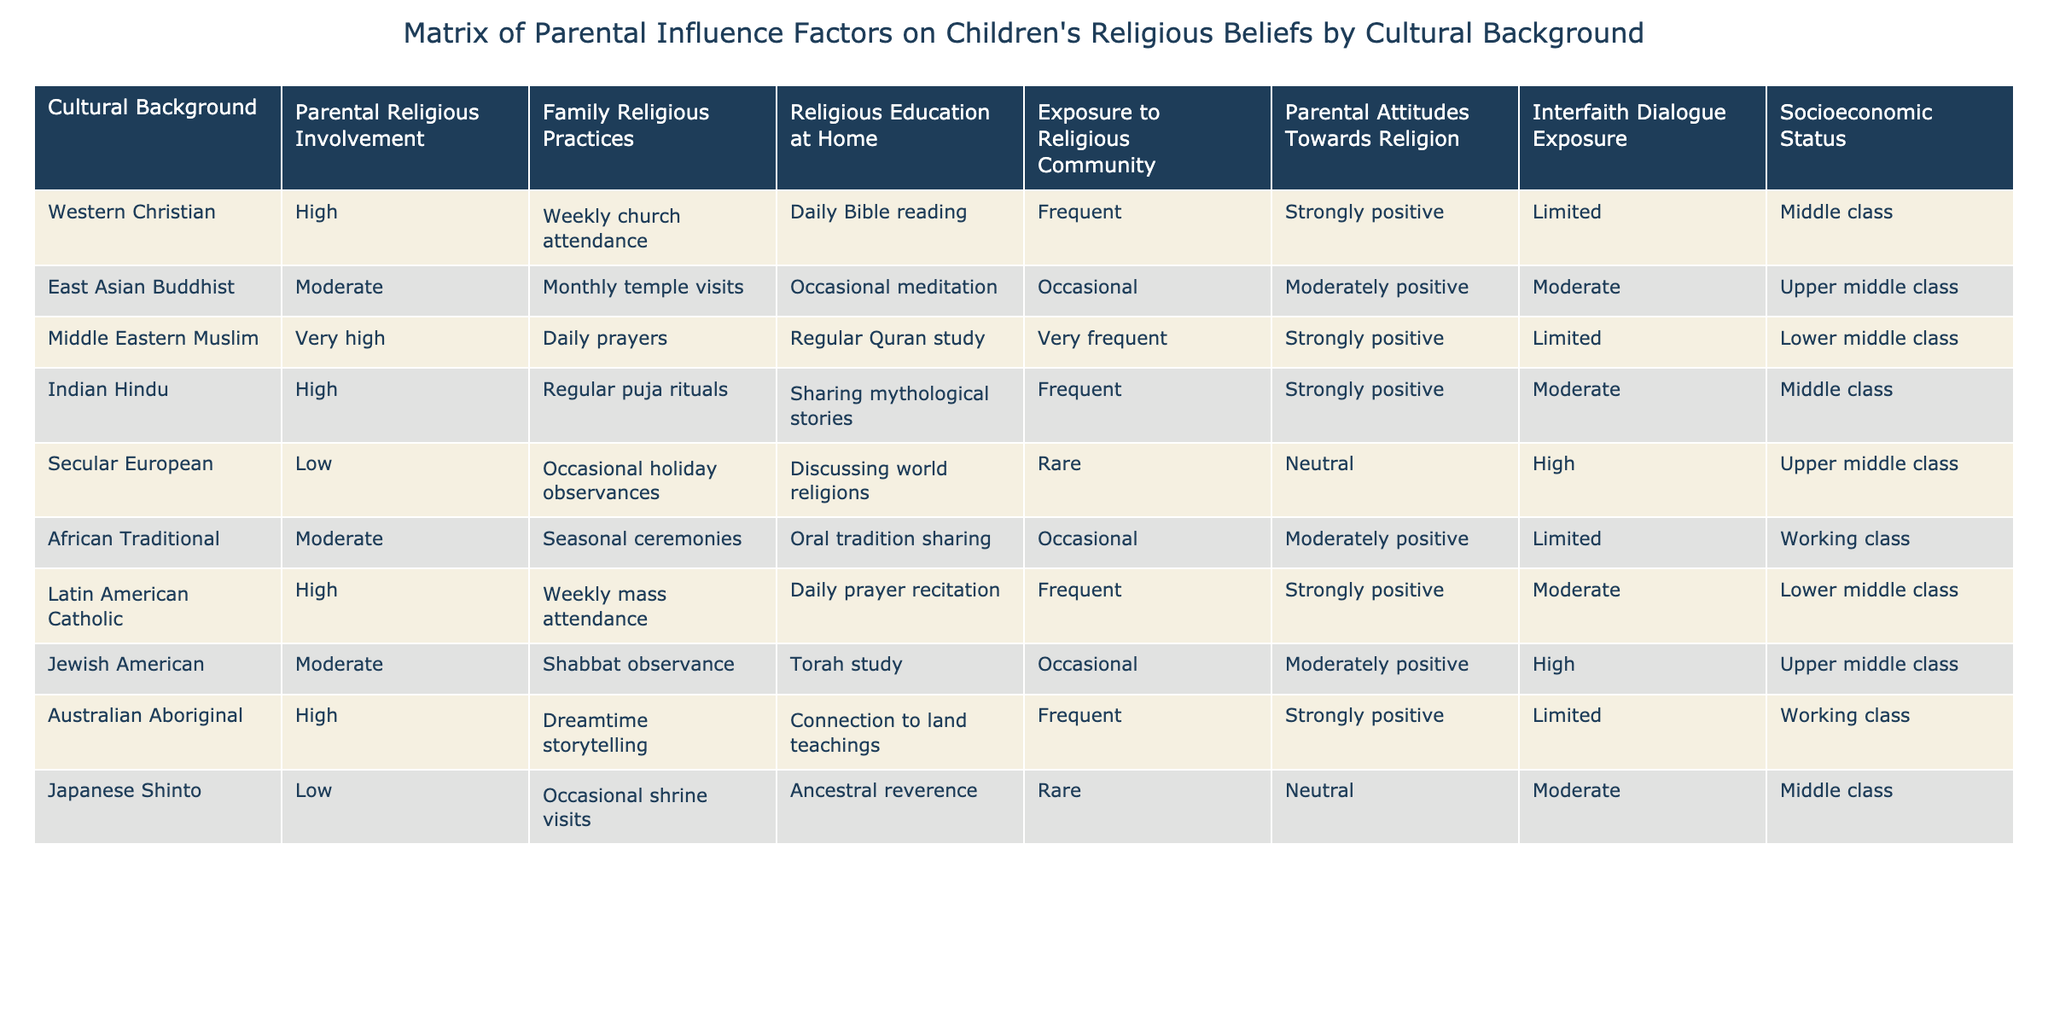What is the parental religious involvement level for the Middle Eastern Muslim background? The table indicates that the parental religious involvement level for the Middle Eastern Muslim background is "Very high."
Answer: Very high Which cultural background has the highest frequency of family religious practices? The Middle Eastern Muslim background shows "Daily prayers," indicating the highest frequency among the listed backgrounds.
Answer: Daily prayers Are exposure to religious communities and parental attitudes towards religion positively correlated in the Latin American Catholic background? The Latin American Catholic background has "Frequent" exposure to religious communities and "Strongly positive" parental attitudes, indicating a positive correlation.
Answer: Yes What is the socioeconomic status of the Secular European cultural background? The table shows that the socioeconomic status for the Secular European cultural background is "Upper middle class."
Answer: Upper middle class Which cultural background exhibits the least parental religious involvement? The Secular European background exhibits the least parental religious involvement with a level of "Low."
Answer: Low How many cultural backgrounds have moderate parental attitudes towards religion? The East Asian Buddhist and Jewish American cultural backgrounds both have "Moderately positive" parental attitudes, making a total of two.
Answer: 2 What is the difference in religious education at home between Australian Aboriginal and Japanese Shinto backgrounds? The Australian Aboriginal background has "Frequent" religious education while the Japanese Shinto has "Rare," making the difference - from frequent to rare.
Answer: Frequent - Rare Is there any background that has high parental involvement but low exposure to religious communities? The Australian Aboriginal background has "High" parental involvement but "Limited" exposure to religious communities.
Answer: Yes What can be said about the relationship between socioeconomic status and family religious practices in the East Asian Buddhist background? The East Asian Buddhist background has "Upper middle class" socioeconomic status and "Monthly temple visits" for family religious practices, indicating a reasonable involvement with religion despite higher status.
Answer: Moderate involvement Which cultural background combines low parental influence with high exposure to interfaith dialogue? The Secular European background has "Low" parental influence and "High" exposure to interfaith dialogue.
Answer: Secular European 